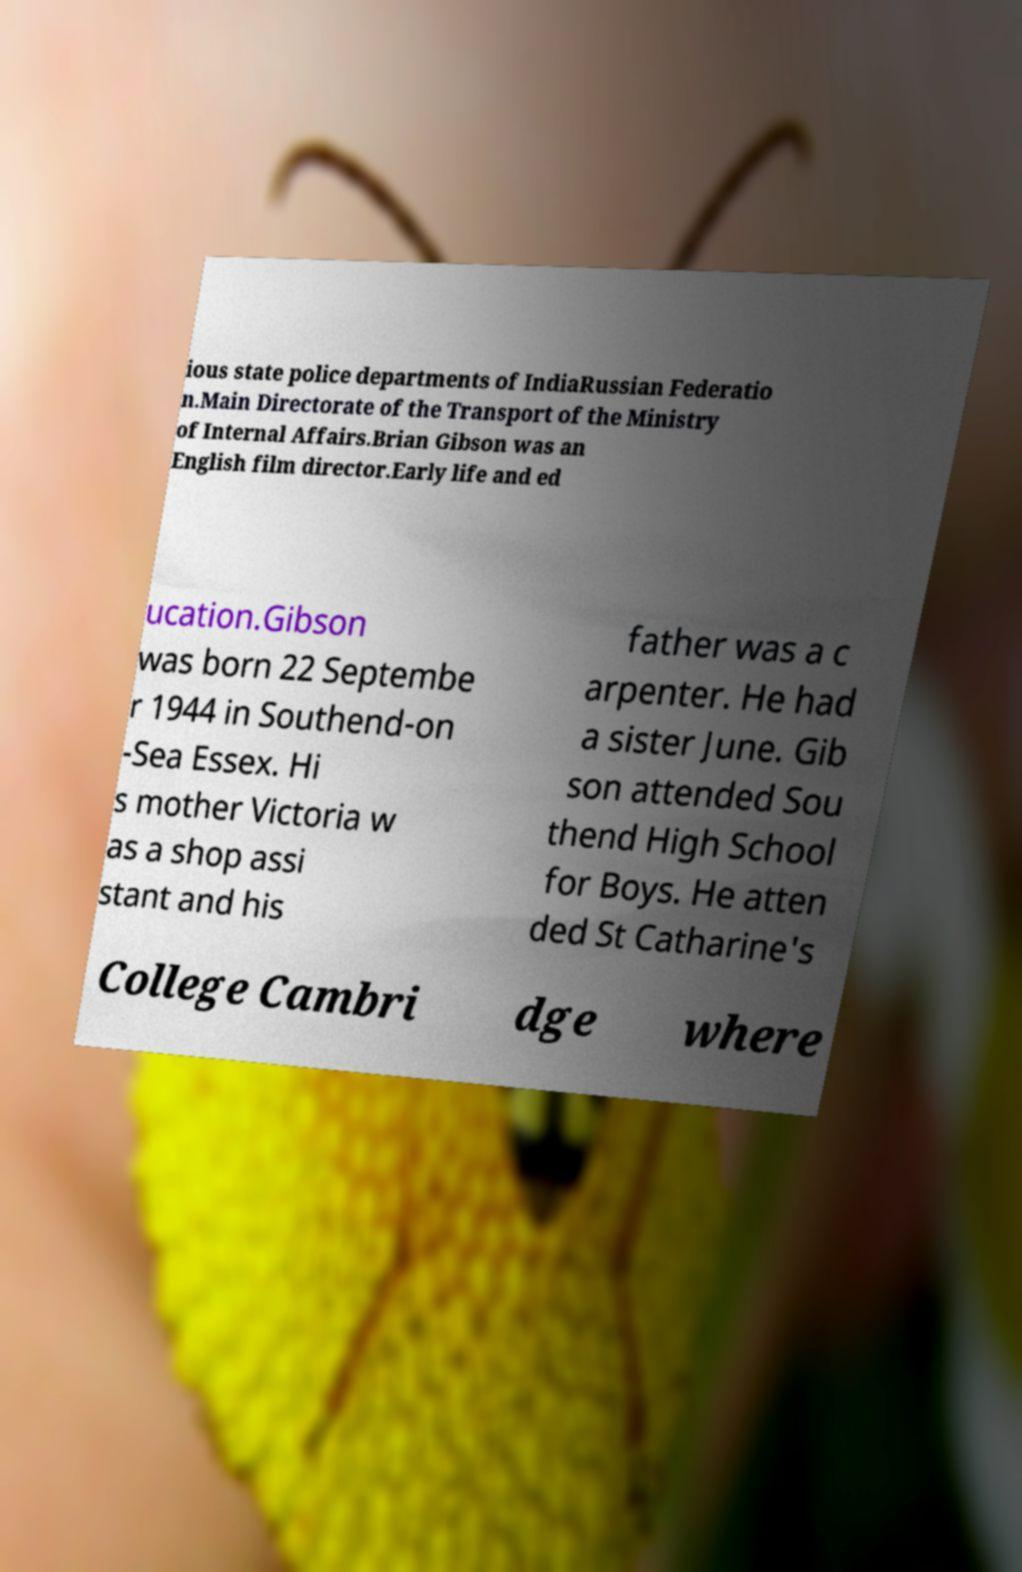Could you assist in decoding the text presented in this image and type it out clearly? ious state police departments of IndiaRussian Federatio n.Main Directorate of the Transport of the Ministry of Internal Affairs.Brian Gibson was an English film director.Early life and ed ucation.Gibson was born 22 Septembe r 1944 in Southend-on -Sea Essex. Hi s mother Victoria w as a shop assi stant and his father was a c arpenter. He had a sister June. Gib son attended Sou thend High School for Boys. He atten ded St Catharine's College Cambri dge where 